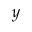<formula> <loc_0><loc_0><loc_500><loc_500>y</formula> 